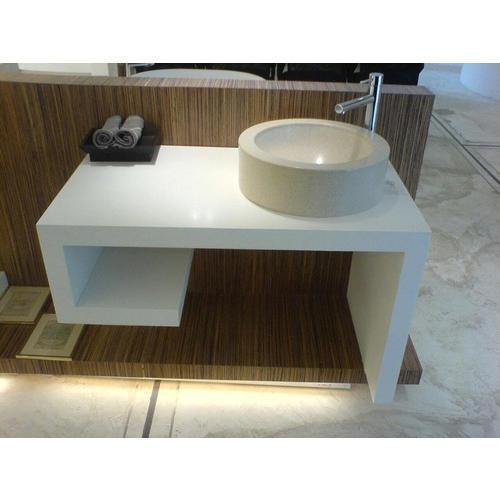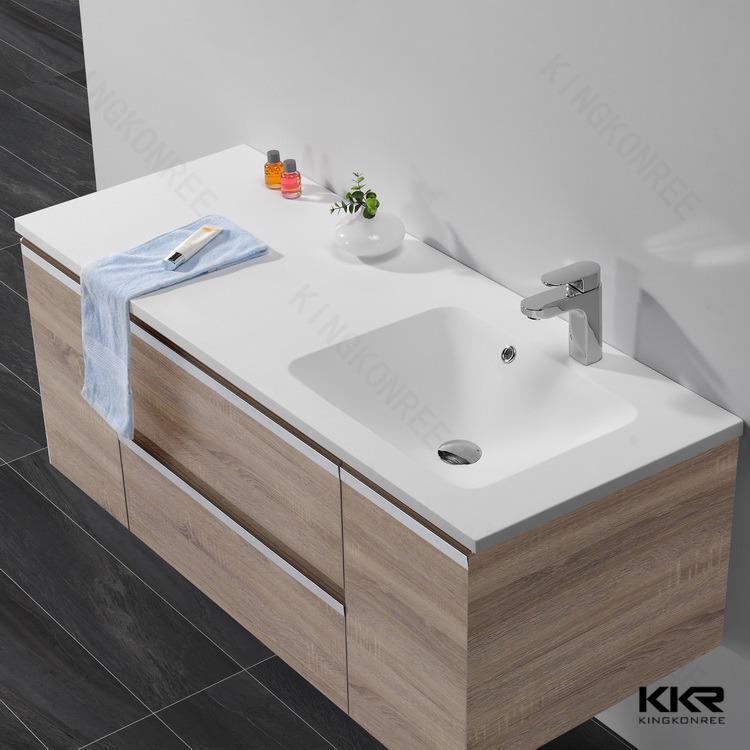The first image is the image on the left, the second image is the image on the right. Considering the images on both sides, is "One sink is round and the other is rectangular; also, one sink is inset, and the other is elevated above the counter." valid? Answer yes or no. Yes. The first image is the image on the left, the second image is the image on the right. Assess this claim about the two images: "One of images shows folded towels stored beneath the sink.". Correct or not? Answer yes or no. No. 